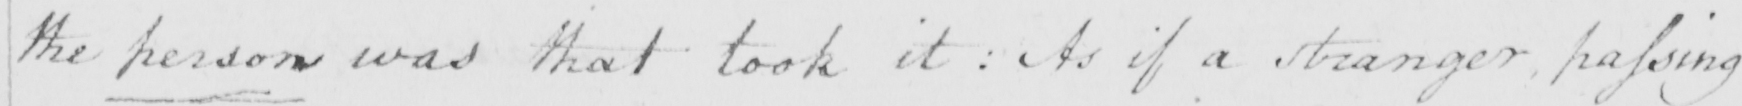What does this handwritten line say? the person was that took it :  As if a stranger passing 